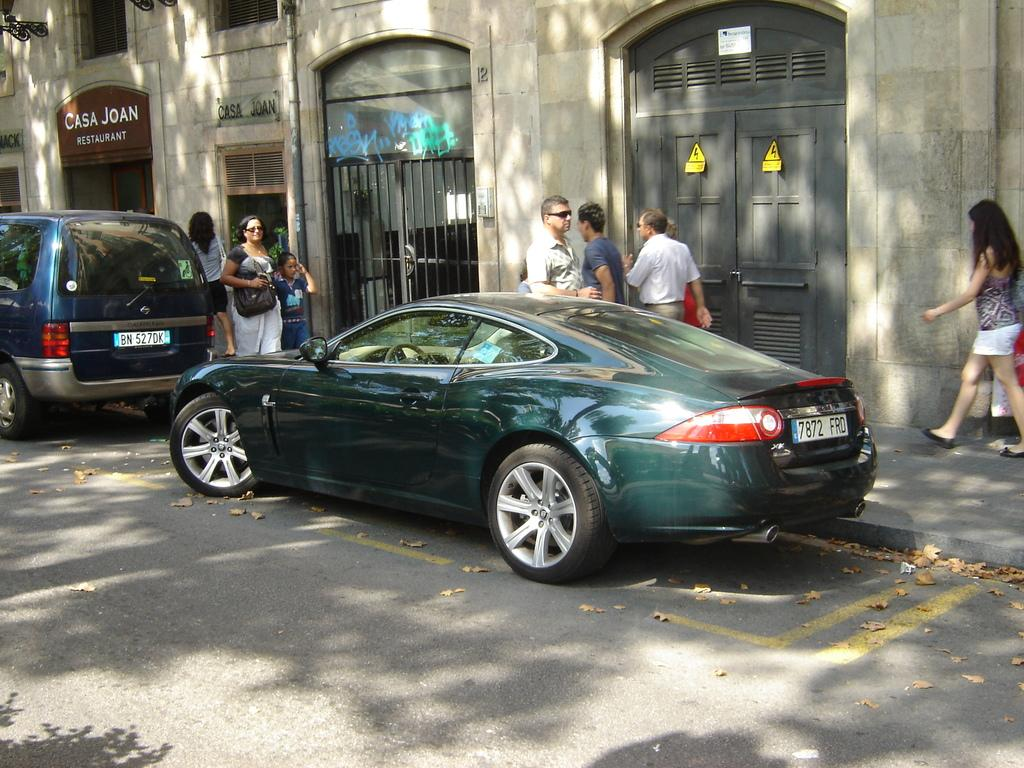What can be seen on the road in the image? There are two cars parked on the road. What are the people in the image doing? There are people walking on the pavement behind the cars. What is visible in the background of the image? There is a building in the background of the image. How many sacks can be seen on the pavement in the image? There are no sacks visible in the image; it features two parked cars and people walking on the pavement. What type of rings are being worn by the people walking on the pavement? There is no indication of any rings being worn by the people in the image. 